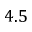<formula> <loc_0><loc_0><loc_500><loc_500>4 . 5</formula> 